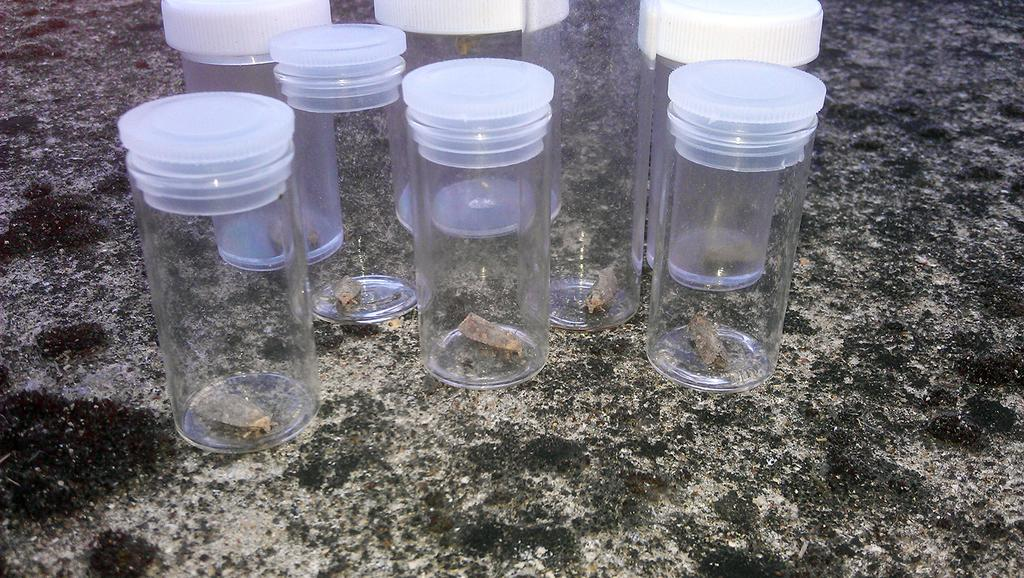What is the main subject of the image? The main subject of the image is many bottles. What is inside the bottles? Insects are inside the bottles. What feature do the bottles have to keep their contents secure? The bottles have caps. What type of religion is being practiced in the image? There is no indication of any religious practice in the image; it features bottles with insects inside. What type of soda is being served in the image? There is no soda present in the image; it features bottles with insects inside. 